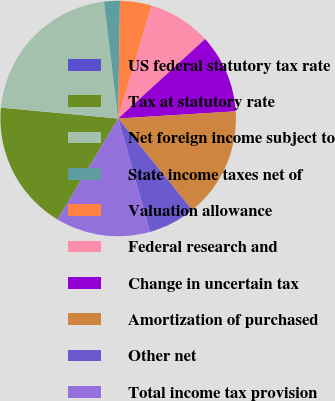Convert chart. <chart><loc_0><loc_0><loc_500><loc_500><pie_chart><fcel>US federal statutory tax rate<fcel>Tax at statutory rate<fcel>Net foreign income subject to<fcel>State income taxes net of<fcel>Valuation allowance<fcel>Federal research and<fcel>Change in uncertain tax<fcel>Amortization of purchased<fcel>Other net<fcel>Total income tax provision<nl><fcel>0.0%<fcel>17.86%<fcel>21.61%<fcel>2.16%<fcel>4.32%<fcel>8.65%<fcel>10.81%<fcel>15.13%<fcel>6.48%<fcel>12.97%<nl></chart> 